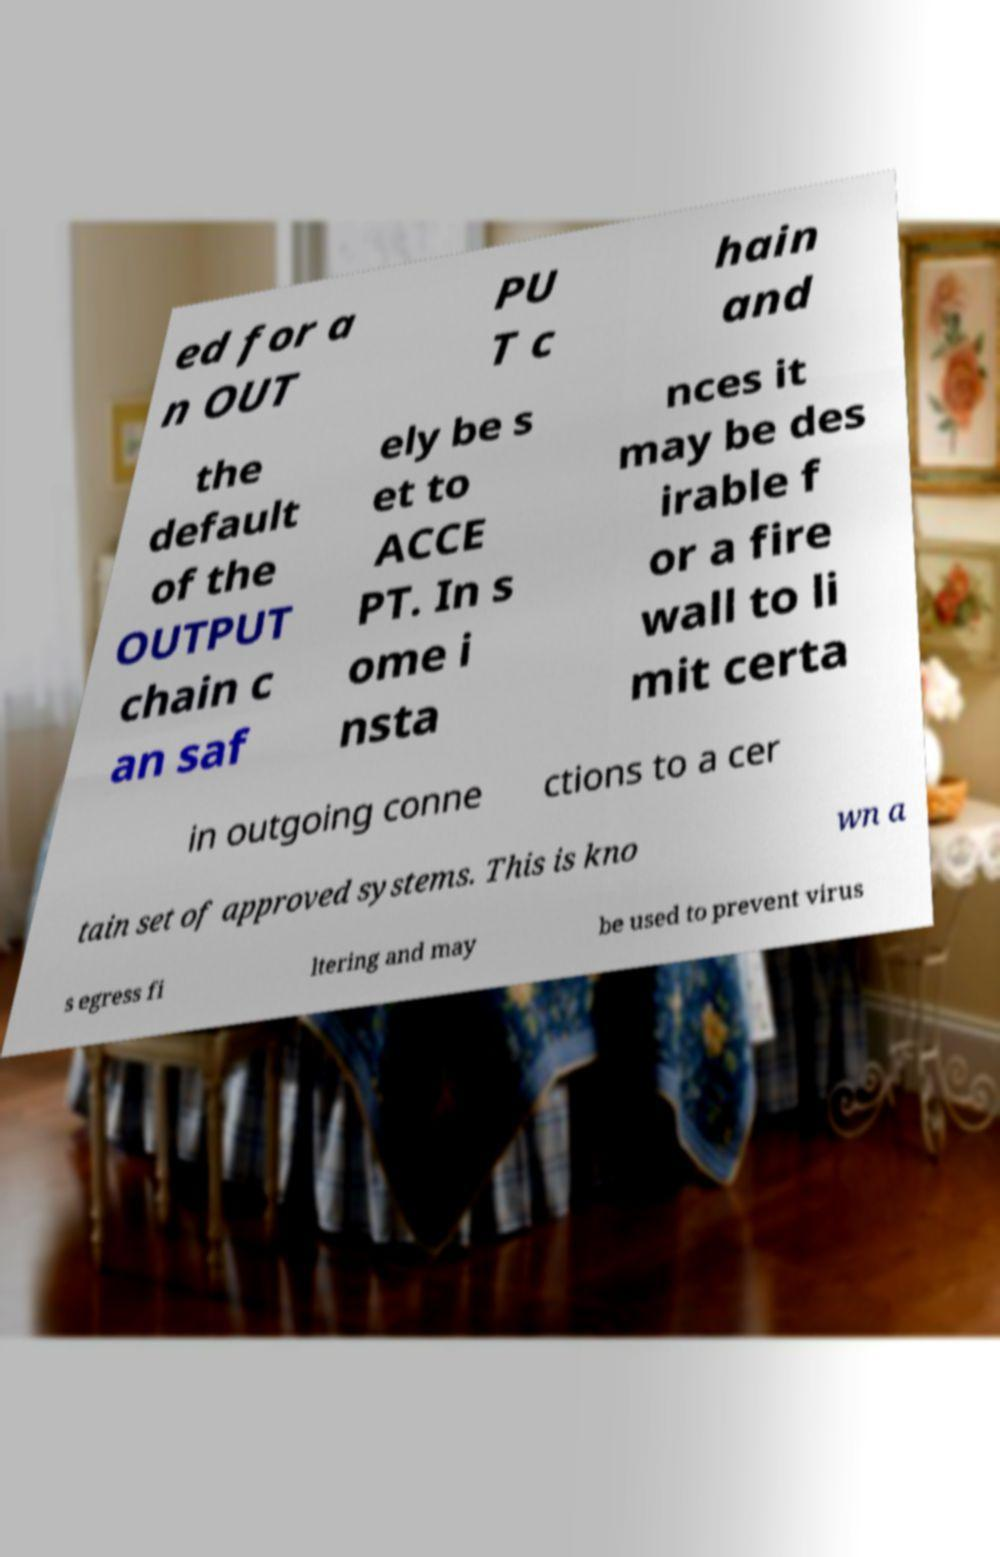Please identify and transcribe the text found in this image. ed for a n OUT PU T c hain and the default of the OUTPUT chain c an saf ely be s et to ACCE PT. In s ome i nsta nces it may be des irable f or a fire wall to li mit certa in outgoing conne ctions to a cer tain set of approved systems. This is kno wn a s egress fi ltering and may be used to prevent virus 